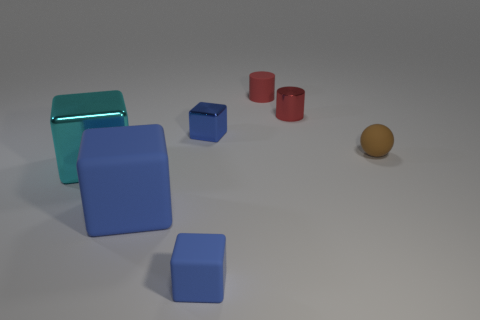Subtract all blue cylinders. How many blue blocks are left? 3 Subtract 1 cubes. How many cubes are left? 3 Add 2 tiny spheres. How many objects exist? 9 Subtract all cylinders. How many objects are left? 5 Add 3 big cyan objects. How many big cyan objects exist? 4 Subtract 0 gray balls. How many objects are left? 7 Subtract all blue metal objects. Subtract all cyan shiny blocks. How many objects are left? 5 Add 7 blue metallic objects. How many blue metallic objects are left? 8 